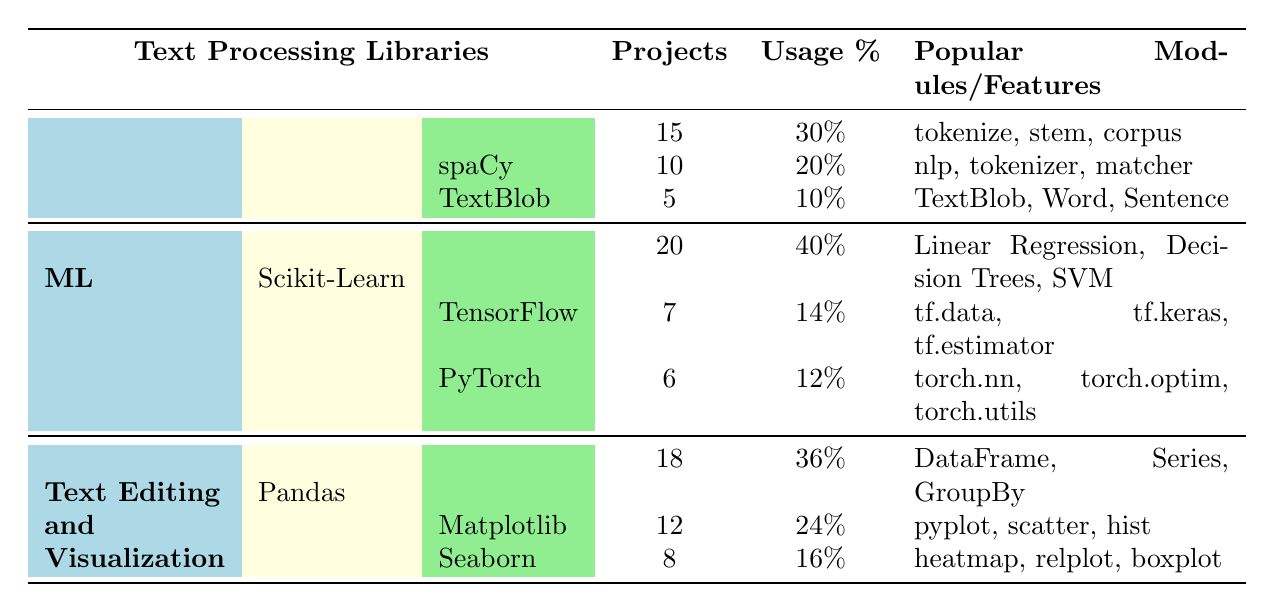What library has the highest usage percentage? From the table, we can see that the usage percentage is highest for Scikit-Learn at 40%.
Answer: Scikit-Learn How many projects used NLTK? The table indicates that NLTK was used in 15 projects.
Answer: 15 What is the total number of projects that used machine learning libraries? By adding up the projects used for machine learning libraries: 20 (Scikit-Learn) + 7 (TensorFlow) + 6 (PyTorch) = 33.
Answer: 33 Which library belongs to the Text Editing and Visualization category and has the lowest usage percentage? The libraries listed under Text Editing and Visualization are Pandas (36%), Matplotlib (24%), and Seaborn (16%). The lowest usage percentage belongs to Seaborn at 16%.
Answer: Seaborn Is the percentage of projects using spaCy greater than that using TextBlob? Comparing the usage percentages: spaCy has 20%, whereas TextBlob has 10%. Therefore, spaCy’s percentage is indeed greater.
Answer: Yes What is the average number of projects across all NLP libraries? To find the average, we calculate the sum of projects for NLP libraries: 15 (NLTK) + 10 (spaCy) + 5 (TextBlob) = 30 projects. There are 3 libraries, so the average is 30/3 = 10.
Answer: 10 Which library has the same count of projects as TensorFlow? From the table, TensorFlow has 7 projects. PyTorch also has 6 projects, which is close but not equivalent. Hence, no library has the same count as TensorFlow.
Answer: None How many more projects used NLTK compared to PyTorch? NLTK has 15 projects while PyTorch has 6. The difference is calculated as 15 - 6 = 9, meaning NLTK was used in 9 more projects than PyTorch.
Answer: 9 Which NLP library has the fewest projects, and how many projects are those? Among NLTK (15), spaCy (10), and TextBlob (5), the fewest projects are for TextBlob, which has 5 projects.
Answer: TextBlob, 5 